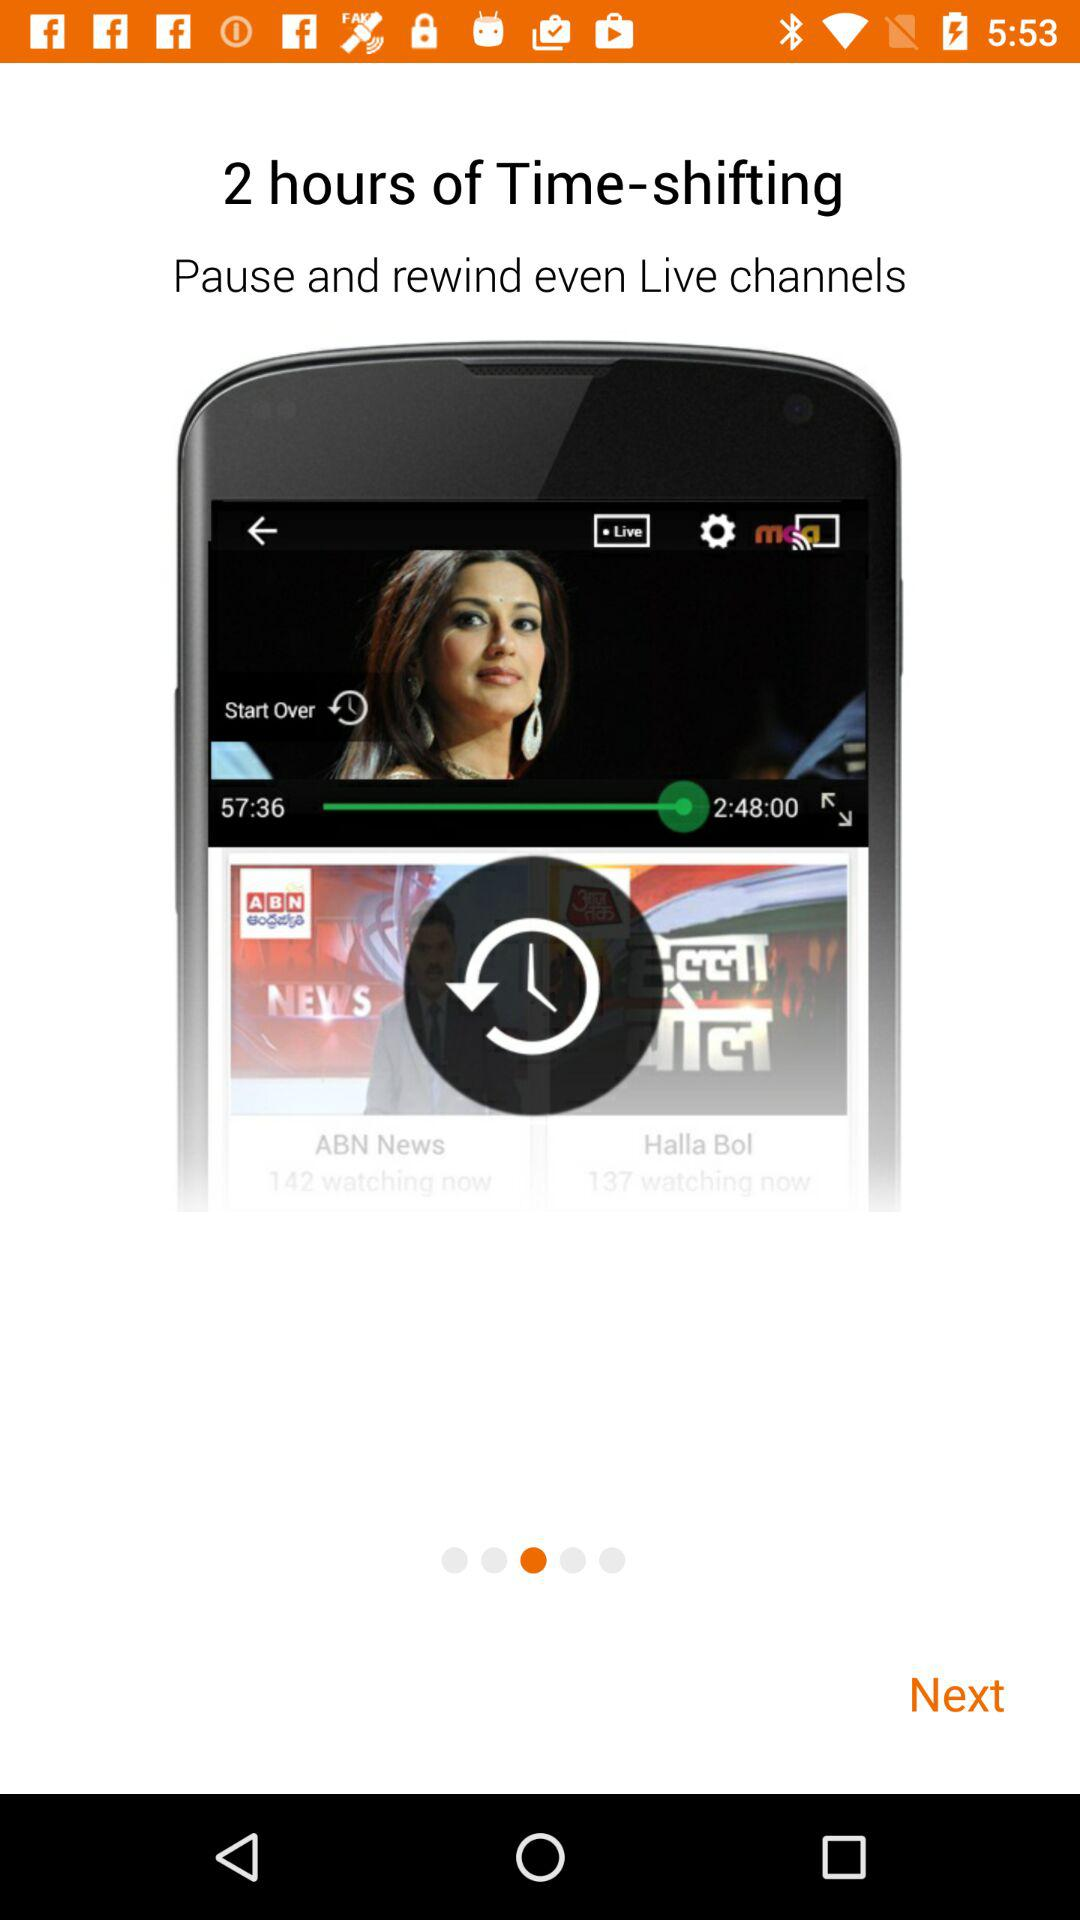What is the duration of time shifting? The duration is 2 hours. 